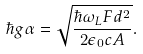<formula> <loc_0><loc_0><loc_500><loc_500>\hbar { g } \alpha = \sqrt { \frac { \hbar { \omega } _ { L } F d ^ { 2 } } { 2 \epsilon _ { 0 } c A } } .</formula> 